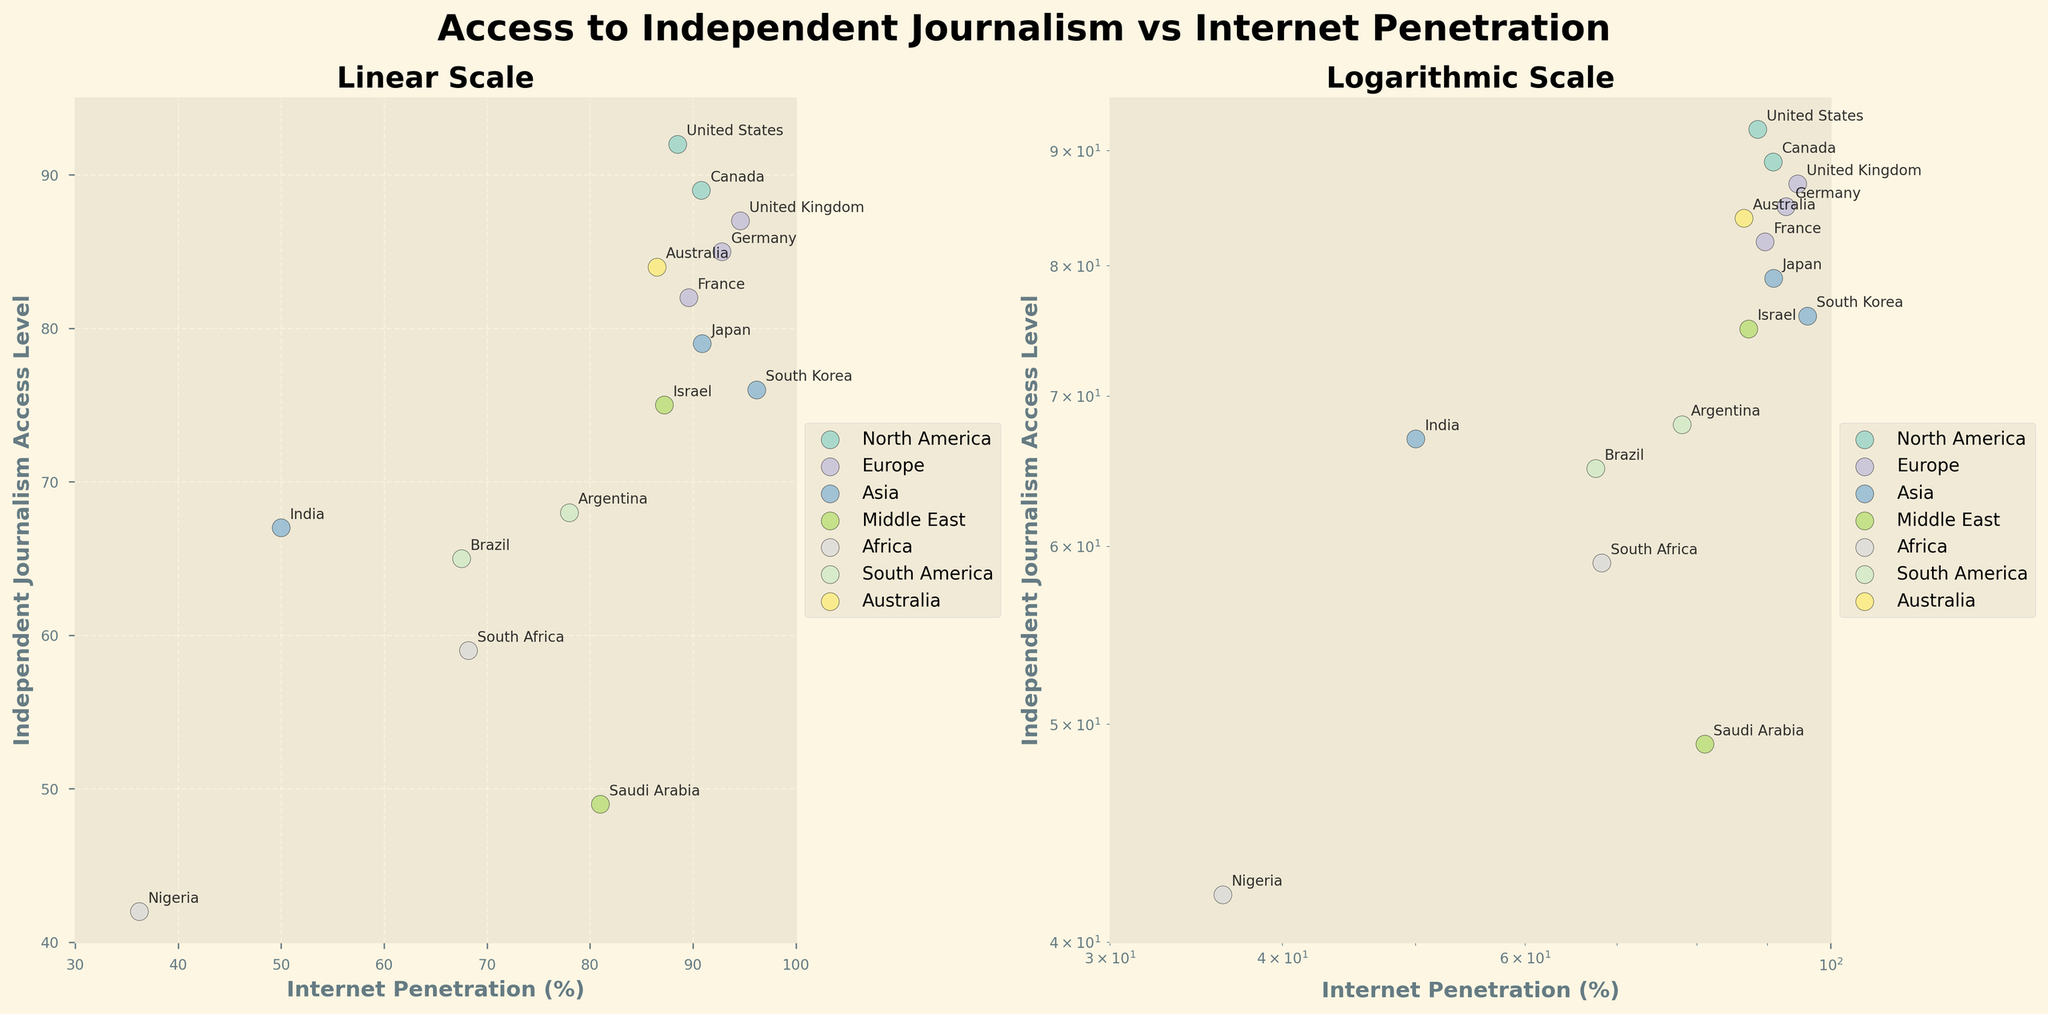What are the titles of the two subplots? The titles can be found at the top of each subplot. The left subplot is titled "Linear Scale," and the right subplot is titled "Logarithmic Scale."
Answer: Linear Scale, Logarithmic Scale Which region has the highest independent journalism access level in the linear scale subplot? This can be determined by looking at the highest point on the y-axis in the linear scale subplot, which belongs to the United States in North America.
Answer: North America (United States) How does the internet penetration in Nigeria compare to that in Australia on both subplots? In both subplots, Nigeria has an internet penetration of 36.2%, while Australia has a penetration of 86.5%. Therefore, Australia's internet penetration is significantly higher than Nigeria's in both linear and logarithmic scales.
Answer: Australia's is higher What is the approximate independent journalism access level in Argentina? By looking at the figure and finding the data point labeled "Argentina," we can see that its independent journalism access level is around 68%.
Answer: 68% On the logarithmic scale subplot, how does the independent journalism access level of Japan compare to South Korea? We can observe from the labels and vertical positions of the data points in the logarithmic scale subplot, Japan has a higher independent journalism access level (79%) compared to South Korea (76%).
Answer: Japan's is higher Which country in South America has a lower independent journalism access level and what is that level? By looking at the subplot, Brazil (65%) has a lower access level compared to Argentina (68%) in South America.
Answer: Brazil, 65% How many unique regions are represented in the figure? The legend on both subplots shows the different colors representing each region. There are seven unique regions: North America, Europe, Asia, Middle East, Africa, South America, and Australia.
Answer: Seven In the log scale subplot, which country has the lowest internet penetration? By scrutinizing the horizontal axis in the log scale subplot, we can see that Nigeria has the lowest internet penetration at 36.2%.
Answer: Nigeria Compare the general trend between internet penetration and independent journalism access level in the linear and log scale subplots. Both subplots show a positive correlation between internet penetration and independent journalism access level: as internet penetration increases, so does access to independent journalism. This trend is consistent in both linear and logarithmic scales but is more spread out in the log scale due to the nature of logarithmic representation.
Answer: Positive correlation in both Which data point has the lowest independent journalism access level and in which region is it located? By looking at the lowest data point on the y-axis, we can identify Saudi Arabia in the Middle East with an independent journalism access level of 49%.
Answer: Saudi Arabia, Middle East 